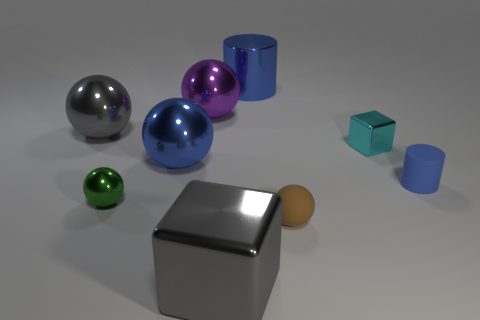Are there any other things that are the same color as the large metal block? Yes, there is one small cylindrical object to the right that shares the same silver color as the large metal block. 